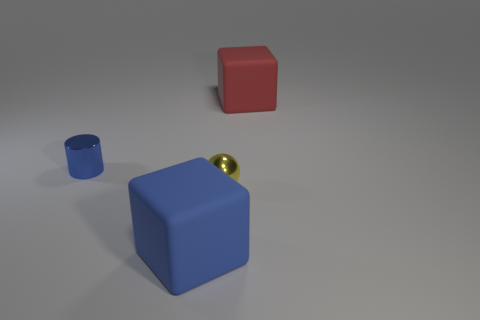Add 3 large cyan shiny balls. How many objects exist? 7 Subtract all spheres. How many objects are left? 3 Subtract 1 blocks. How many blocks are left? 1 Subtract all red cubes. How many cubes are left? 1 Subtract all gray cylinders. How many red cubes are left? 1 Subtract all red cubes. Subtract all big blue rubber blocks. How many objects are left? 2 Add 3 matte cubes. How many matte cubes are left? 5 Add 1 big red spheres. How many big red spheres exist? 1 Subtract 0 cyan spheres. How many objects are left? 4 Subtract all blue spheres. Subtract all red cylinders. How many spheres are left? 1 